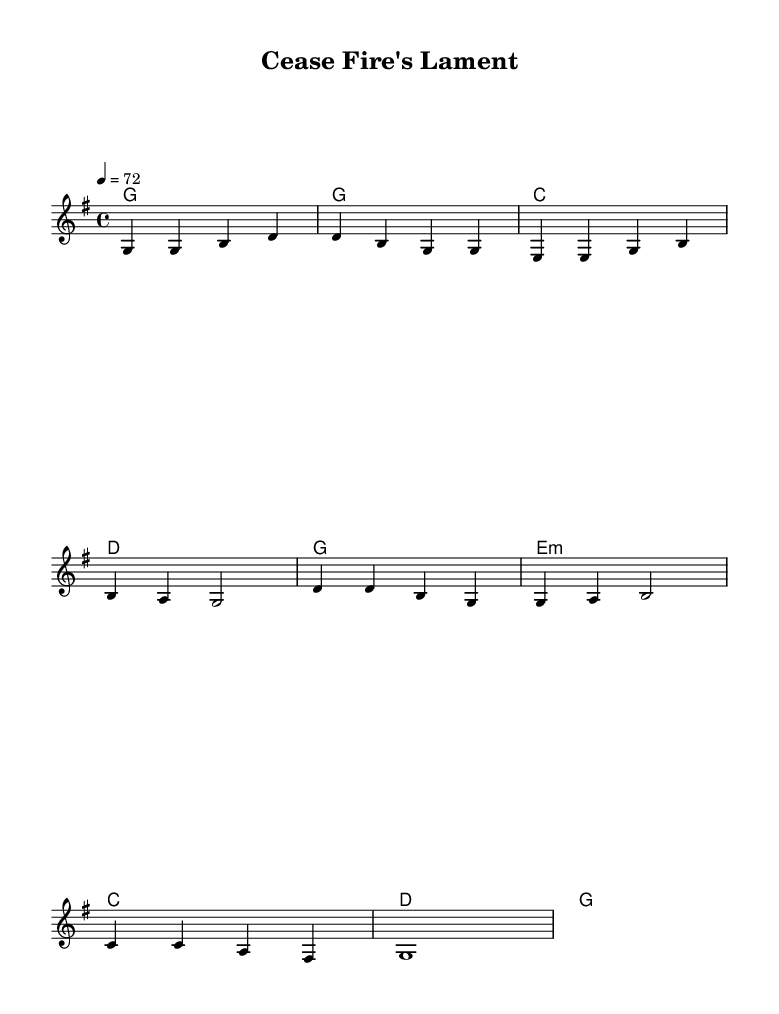What is the key signature of this music? The key signature is G major, which has one sharp (F#). This can be identified by looking at the key signature notation at the beginning of the staff, which indicates the presence of one sharp.
Answer: G major What is the time signature of this music? The time signature is 4/4, as indicated at the beginning of the score. This means there are four beats in a measure and the quarter note receives one beat.
Answer: 4/4 What is the tempo marking? The tempo marking is quarter note equals 72, meaning there are 72 quarter note beats per minute. This information is found under the tempo directive at the beginning of the music.
Answer: 72 How many measures are in the verse section? The verse section consists of four measures, as seen in the notation before the chorus begins. Each set of four beats represents a measure, and by counting the distinct segments, we find four.
Answer: 4 What is the mood suggested by the title "Cease Fire's Lament"? The title “Lament” suggests a sorrowful or mournful mood, typically associated with loss or conflict. This is inferred from the word "lament," which indicates expressing grief or sorrow.
Answer: Sorrowful How does the melody change between the verse and chorus? The melody maintains a similar range but introduces different notes when transitioning from the verse to the chorus, showcasing variation in musical expression. By comparing the pitches in the melody for both sections, one can see the differences in note usage.
Answer: Variation 